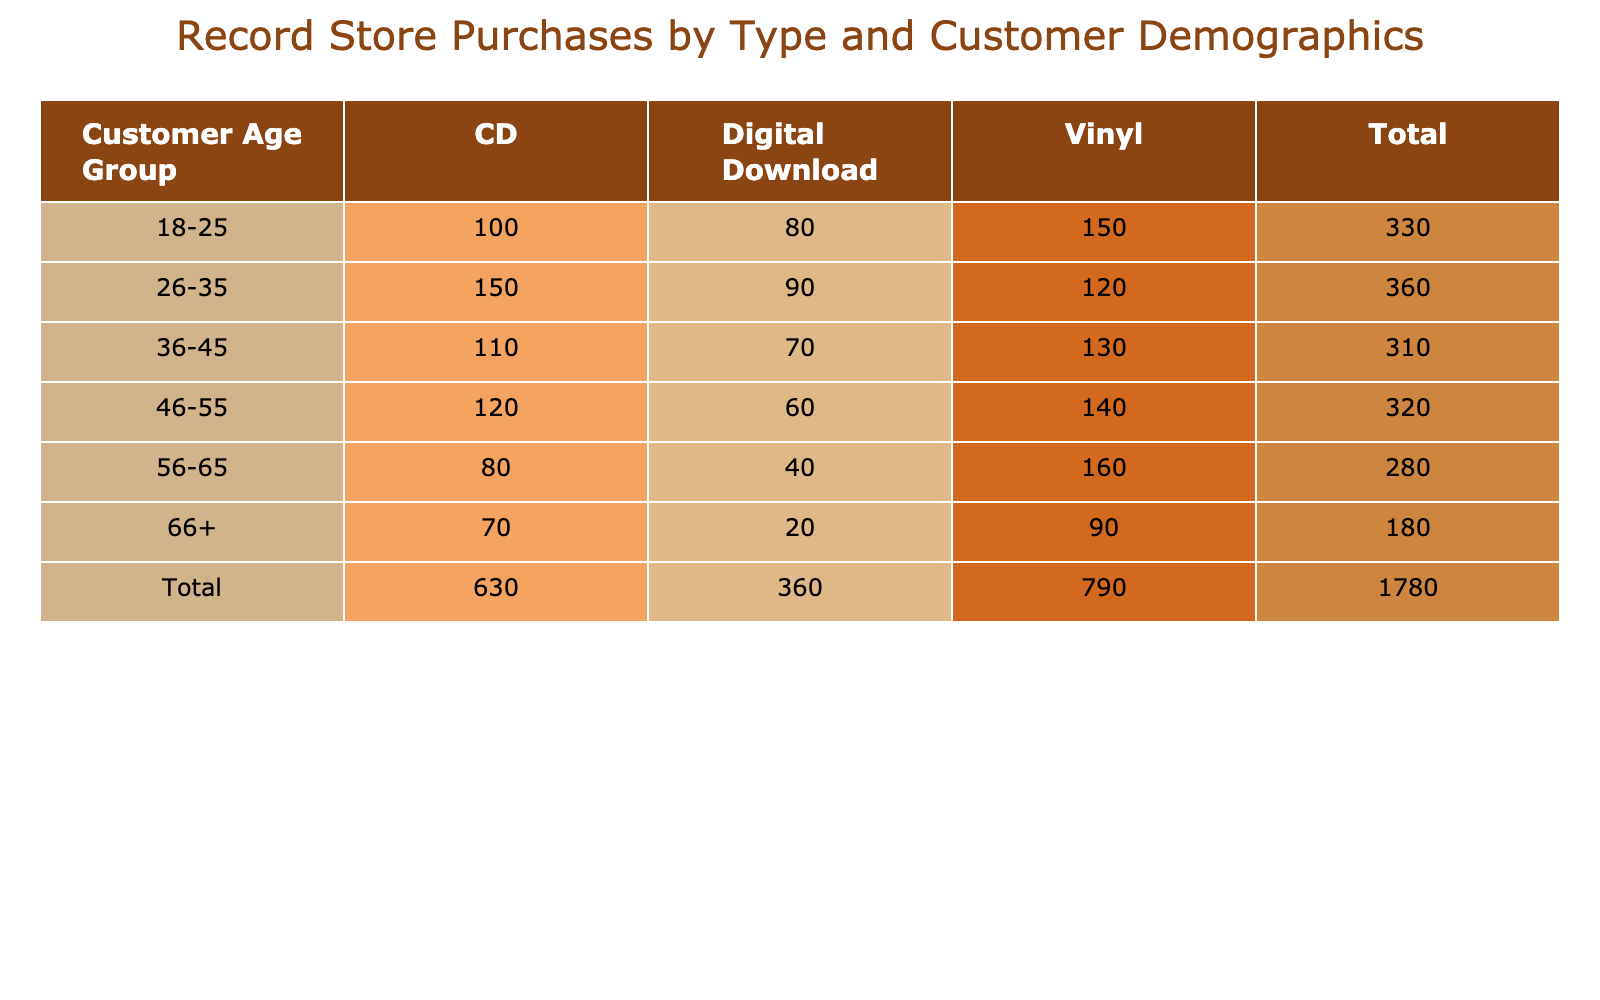What is the total number of Vinyl purchases by customers aged 36-45? The table shows that for the age group 36-45, there were 130 purchases of Vinyl records.
Answer: 130 Which age group purchased the most Digital Downloads? Looking at the Digital Download column, the age group 18-25 purchased 80, 26-35 purchased 90, 36-45 purchased 70, 46-55 purchased 60, 56-65 purchased 40, and 66+ purchased 20. The age group 26-35 has the highest count of 90 purchases.
Answer: 26-35 Is it true that more customers aged 56-65 purchased Vinyl than those aged 46-55? For the age group 56-65, there were 160 Vinyl purchases, while for 46-55, there were 140 Vinyl purchases. Since 160 is greater than 140, the statement is true.
Answer: Yes How many more CD purchases were made by the 26-35 age group compared to the 56-65 age group? The 26-35 age group made 150 CD purchases, while the 56-65 group made 80. Subtracting these gives 150 - 80 = 70 more CD purchases in the 26-35 age group.
Answer: 70 What is the average number of purchases per record type for customers aged 18-25? For this age group, the purchases are 150 (Vinyl) + 100 (CD) + 80 (Digital Download) = 330. Dividing by the number of record types (3) gives an average of 330 / 3 = 110.
Answer: 110 Which record type had the highest total purchases across all age groups? To find this, we sum up each record type: Vinyl: 150+120+130+140+160+90 = 890; CD: 100+150+110+120+80+70 = 630; Digital Download: 80+90+70+60+40+20 = 450. Vinyl has the highest total of 890 purchases.
Answer: Vinyl What is the total number of purchases by the 66+ age group? The total for the 66+ age group is calculated by adding all purchases in that row: 90 (Vinyl) + 70 (CD) + 20 (Digital Download) = 180.
Answer: 180 Did more than half of the 46-55 age group purchases consist of CDs? The 46-55 age group purchased 140 Vinyl, 120 CDs, and 60 Digital Downloads, totaling 140 + 120 + 60 = 320. The breakdown is 120 CDs out of 320 total purchases. Calculating the fraction gives 120 / 320 = 0.375, which is less than half.
Answer: No 